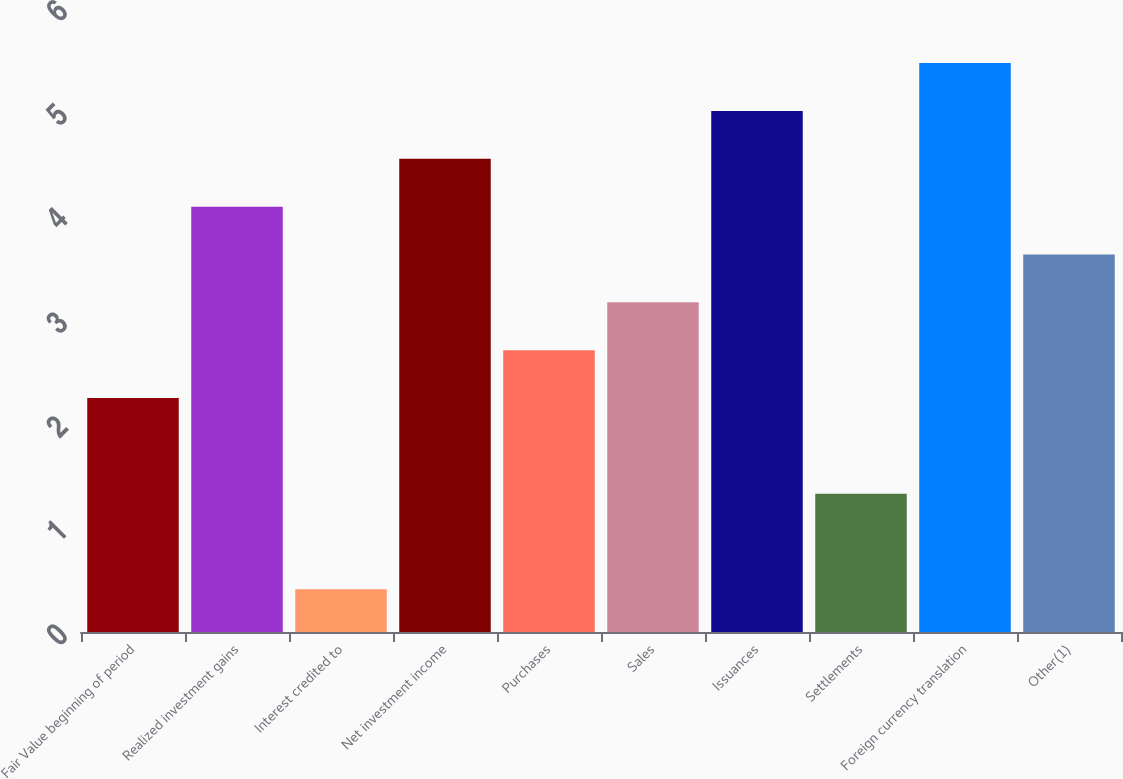Convert chart to OTSL. <chart><loc_0><loc_0><loc_500><loc_500><bar_chart><fcel>Fair Value beginning of period<fcel>Realized investment gains<fcel>Interest credited to<fcel>Net investment income<fcel>Purchases<fcel>Sales<fcel>Issuances<fcel>Settlements<fcel>Foreign currency translation<fcel>Other(1)<nl><fcel>2.25<fcel>4.09<fcel>0.41<fcel>4.55<fcel>2.71<fcel>3.17<fcel>5.01<fcel>1.33<fcel>5.47<fcel>3.63<nl></chart> 